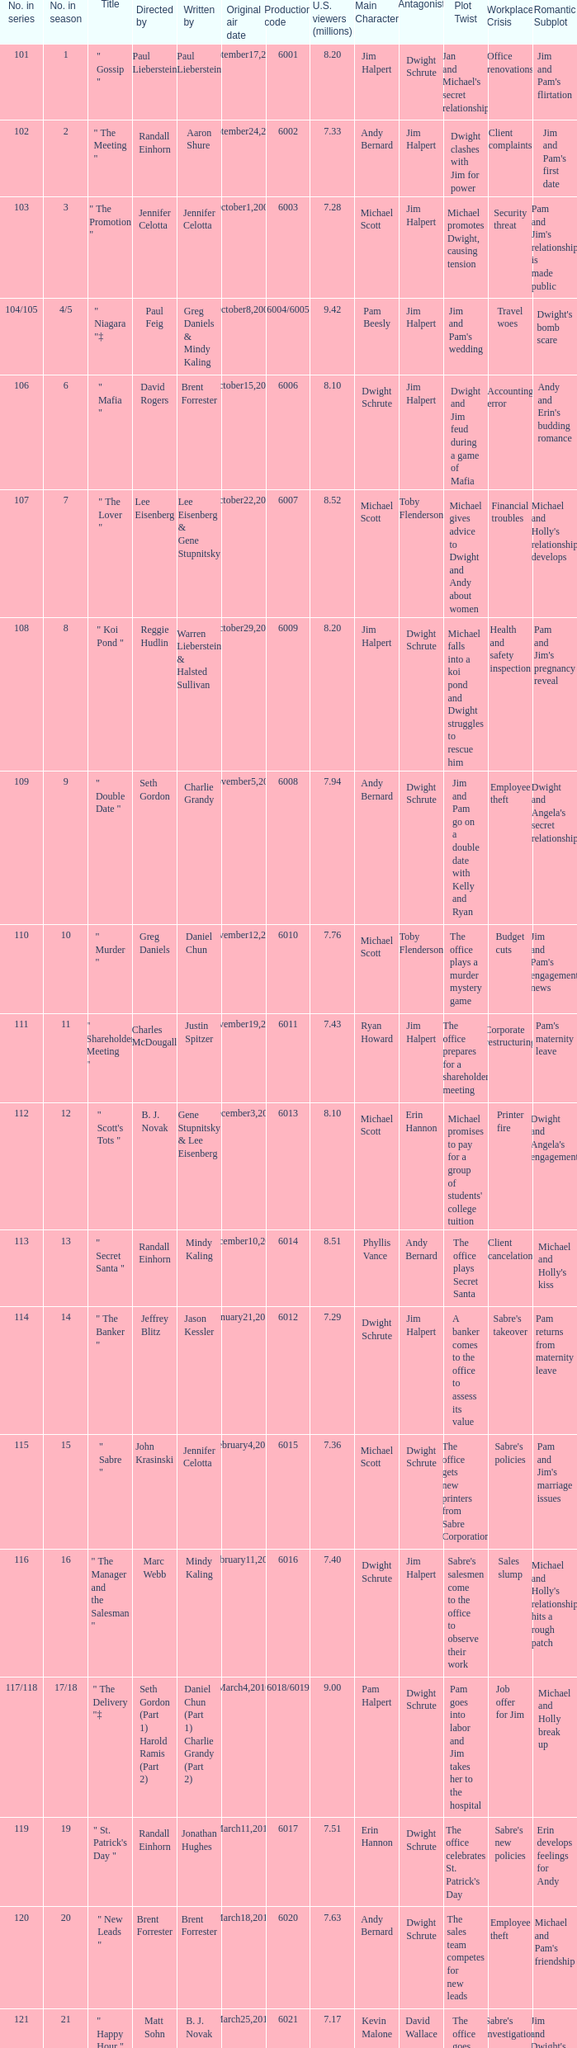Name the production code by paul lieberstein 6001.0. 